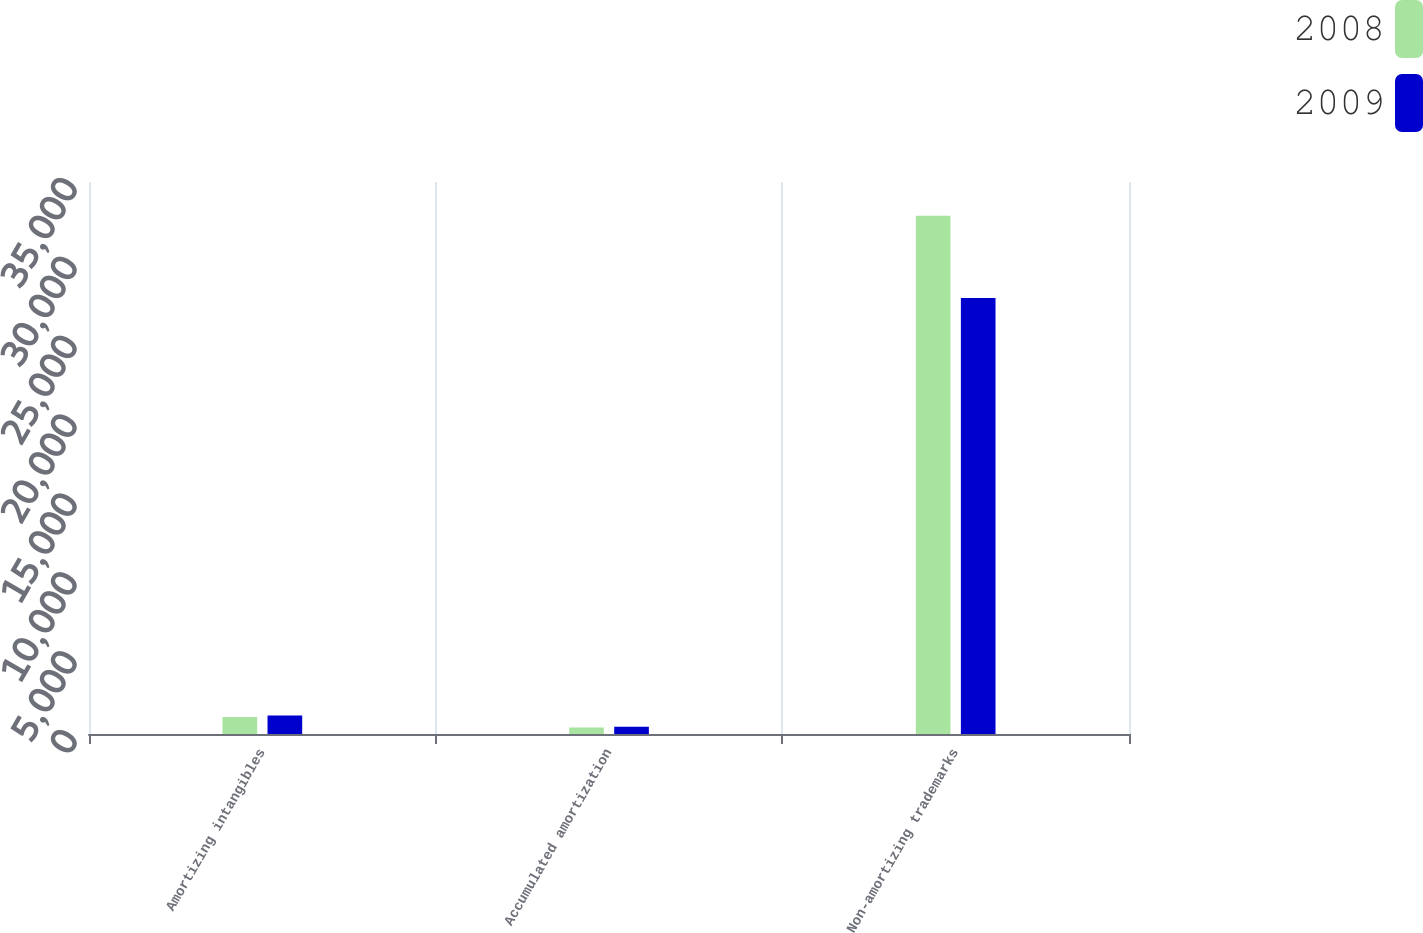<chart> <loc_0><loc_0><loc_500><loc_500><stacked_bar_chart><ecel><fcel>Amortizing intangibles<fcel>Accumulated amortization<fcel>Non-amortizing trademarks<nl><fcel>2008<fcel>1073<fcel>414<fcel>32853<nl><fcel>2009<fcel>1169<fcel>456<fcel>27652<nl></chart> 